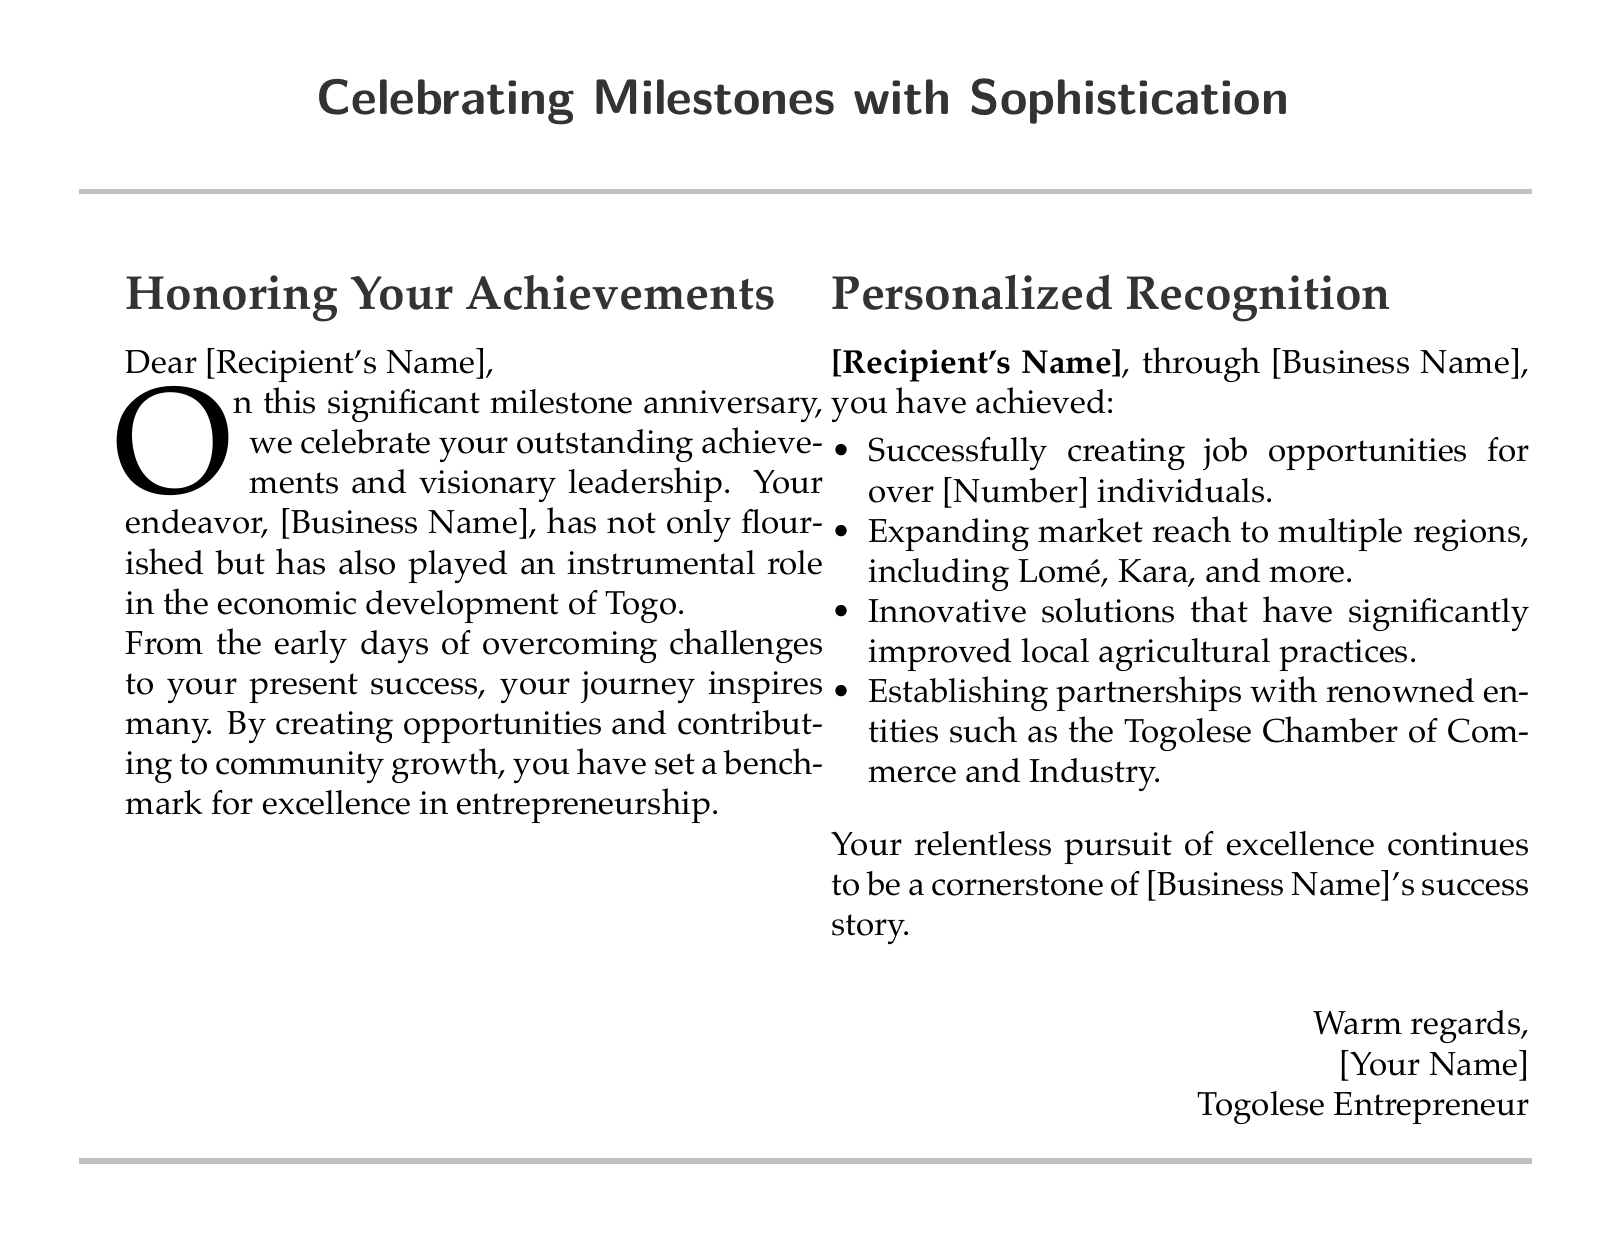What is the title of the card? The title is specified in the header section of the document, which reads "Celebrating Milestones with Sophistication."
Answer: Celebrating Milestones with Sophistication What color is used for the embossing in the document? The document uses a specific RGB color code mentioned in the code for embossing, which corresponds to silver.
Answer: Silver Who is the card addressed to? The card has a placeholder for the recipient's name indicated by "[Recipient's Name]."
Answer: [Recipient's Name] What is the business name mentioned in the document? The business name is referred to with a placeholder in the personalized recognition section as "[Business Name]."
Answer: [Business Name] How many individuals have had job opportunities created through the business? The document mentions a placeholder for the number of individuals, specified as "[Number]."
Answer: [Number] What regions has the business expanded its market reach to? Specific regions are mentioned within the personalized recognition list, including Lomé and Kara.
Answer: Lomé, Kara What is the overall purpose of the card? The primary purpose is to celebrate and honor the achievements and milestones of a recipient's business.
Answer: Celebrate and honor achievements Which notable partnership is mentioned in the document? One of the partnerships specified in the document is with the Togolese Chamber of Commerce and Industry.
Answer: Togolese Chamber of Commerce and Industry What closing phrase is used in the card? The closing phrase is indicated in the sign-off section, "Warm regards."
Answer: Warm regards 